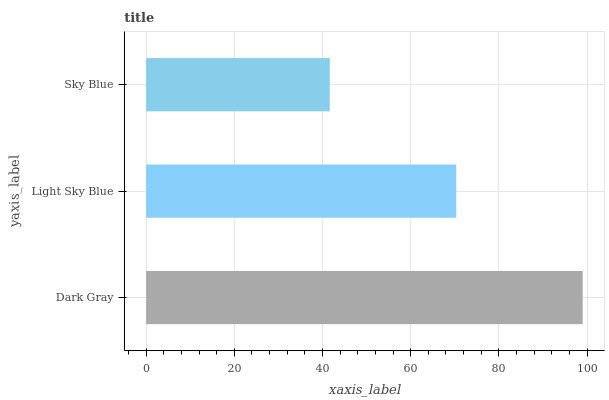Is Sky Blue the minimum?
Answer yes or no. Yes. Is Dark Gray the maximum?
Answer yes or no. Yes. Is Light Sky Blue the minimum?
Answer yes or no. No. Is Light Sky Blue the maximum?
Answer yes or no. No. Is Dark Gray greater than Light Sky Blue?
Answer yes or no. Yes. Is Light Sky Blue less than Dark Gray?
Answer yes or no. Yes. Is Light Sky Blue greater than Dark Gray?
Answer yes or no. No. Is Dark Gray less than Light Sky Blue?
Answer yes or no. No. Is Light Sky Blue the high median?
Answer yes or no. Yes. Is Light Sky Blue the low median?
Answer yes or no. Yes. Is Dark Gray the high median?
Answer yes or no. No. Is Dark Gray the low median?
Answer yes or no. No. 